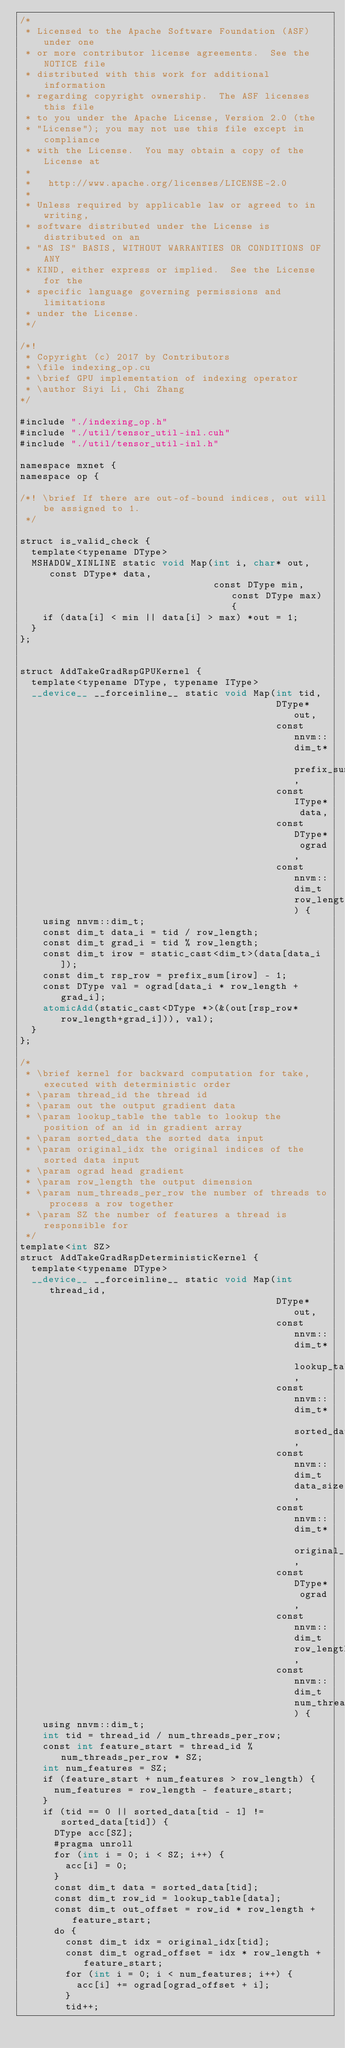Convert code to text. <code><loc_0><loc_0><loc_500><loc_500><_Cuda_>/*
 * Licensed to the Apache Software Foundation (ASF) under one
 * or more contributor license agreements.  See the NOTICE file
 * distributed with this work for additional information
 * regarding copyright ownership.  The ASF licenses this file
 * to you under the Apache License, Version 2.0 (the
 * "License"); you may not use this file except in compliance
 * with the License.  You may obtain a copy of the License at
 *
 *   http://www.apache.org/licenses/LICENSE-2.0
 *
 * Unless required by applicable law or agreed to in writing,
 * software distributed under the License is distributed on an
 * "AS IS" BASIS, WITHOUT WARRANTIES OR CONDITIONS OF ANY
 * KIND, either express or implied.  See the License for the
 * specific language governing permissions and limitations
 * under the License.
 */

/*!
 * Copyright (c) 2017 by Contributors
 * \file indexing_op.cu
 * \brief GPU implementation of indexing operator
 * \author Siyi Li, Chi Zhang
*/

#include "./indexing_op.h"
#include "./util/tensor_util-inl.cuh"
#include "./util/tensor_util-inl.h"

namespace mxnet {
namespace op {

/*! \brief If there are out-of-bound indices, out will be assigned to 1.
 */

struct is_valid_check {
  template<typename DType>
  MSHADOW_XINLINE static void Map(int i, char* out, const DType* data,
                                  const DType min, const DType max) {
    if (data[i] < min || data[i] > max) *out = 1;
  }
};


struct AddTakeGradRspGPUKernel {
  template<typename DType, typename IType>
  __device__ __forceinline__ static void Map(int tid,
                                             DType* out,
                                             const nnvm::dim_t* prefix_sum,
                                             const IType* data,
                                             const DType* ograd,
                                             const nnvm::dim_t row_length) {
    using nnvm::dim_t;
    const dim_t data_i = tid / row_length;
    const dim_t grad_i = tid % row_length;
    const dim_t irow = static_cast<dim_t>(data[data_i]);
    const dim_t rsp_row = prefix_sum[irow] - 1;
    const DType val = ograd[data_i * row_length + grad_i];
    atomicAdd(static_cast<DType *>(&(out[rsp_row*row_length+grad_i])), val);
  }
};

/*
 * \brief kernel for backward computation for take, executed with deterministic order
 * \param thread_id the thread id
 * \param out the output gradient data
 * \param lookup_table the table to lookup the position of an id in gradient array
 * \param sorted_data the sorted data input
 * \param original_idx the original indices of the sorted data input
 * \param ograd head gradient
 * \param row_length the output dimension
 * \param num_threads_per_row the number of threads to process a row together
 * \param SZ the number of features a thread is responsible for
 */
template<int SZ>
struct AddTakeGradRspDeterministicKernel {
  template<typename DType>
  __device__ __forceinline__ static void Map(int thread_id,
                                             DType* out,
                                             const nnvm::dim_t* lookup_table,
                                             const nnvm::dim_t* sorted_data,
                                             const nnvm::dim_t data_size,
                                             const nnvm::dim_t* original_idx,
                                             const DType* ograd,
                                             const nnvm::dim_t row_length,
                                             const nnvm::dim_t num_threads_per_row) {
    using nnvm::dim_t;
    int tid = thread_id / num_threads_per_row;
    const int feature_start = thread_id % num_threads_per_row * SZ;
    int num_features = SZ;
    if (feature_start + num_features > row_length) {
      num_features = row_length - feature_start;
    }
    if (tid == 0 || sorted_data[tid - 1] != sorted_data[tid]) {
      DType acc[SZ];
      #pragma unroll
      for (int i = 0; i < SZ; i++) {
        acc[i] = 0;
      }
      const dim_t data = sorted_data[tid];
      const dim_t row_id = lookup_table[data];
      const dim_t out_offset = row_id * row_length + feature_start;
      do {
        const dim_t idx = original_idx[tid];
        const dim_t ograd_offset = idx * row_length + feature_start;
        for (int i = 0; i < num_features; i++) {
          acc[i] += ograd[ograd_offset + i];
        }
        tid++;</code> 